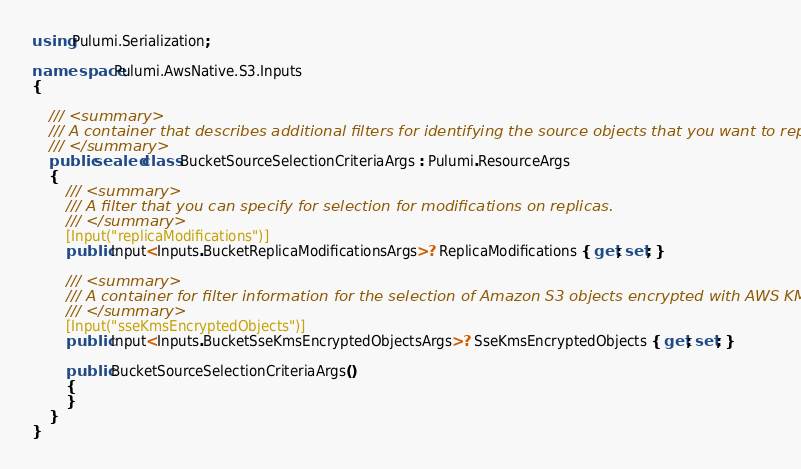Convert code to text. <code><loc_0><loc_0><loc_500><loc_500><_C#_>using Pulumi.Serialization;

namespace Pulumi.AwsNative.S3.Inputs
{

    /// <summary>
    /// A container that describes additional filters for identifying the source objects that you want to replicate.
    /// </summary>
    public sealed class BucketSourceSelectionCriteriaArgs : Pulumi.ResourceArgs
    {
        /// <summary>
        /// A filter that you can specify for selection for modifications on replicas.
        /// </summary>
        [Input("replicaModifications")]
        public Input<Inputs.BucketReplicaModificationsArgs>? ReplicaModifications { get; set; }

        /// <summary>
        /// A container for filter information for the selection of Amazon S3 objects encrypted with AWS KMS.
        /// </summary>
        [Input("sseKmsEncryptedObjects")]
        public Input<Inputs.BucketSseKmsEncryptedObjectsArgs>? SseKmsEncryptedObjects { get; set; }

        public BucketSourceSelectionCriteriaArgs()
        {
        }
    }
}
</code> 